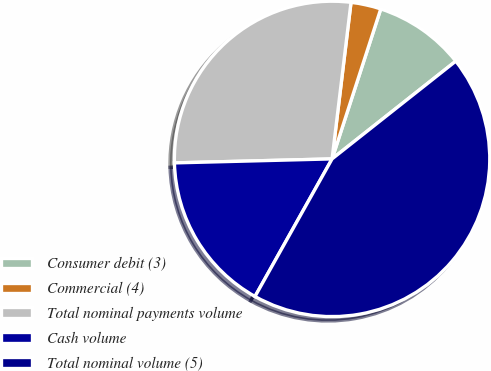Convert chart to OTSL. <chart><loc_0><loc_0><loc_500><loc_500><pie_chart><fcel>Consumer debit (3)<fcel>Commercial (4)<fcel>Total nominal payments volume<fcel>Cash volume<fcel>Total nominal volume (5)<nl><fcel>9.36%<fcel>3.08%<fcel>27.32%<fcel>16.47%<fcel>43.77%<nl></chart> 